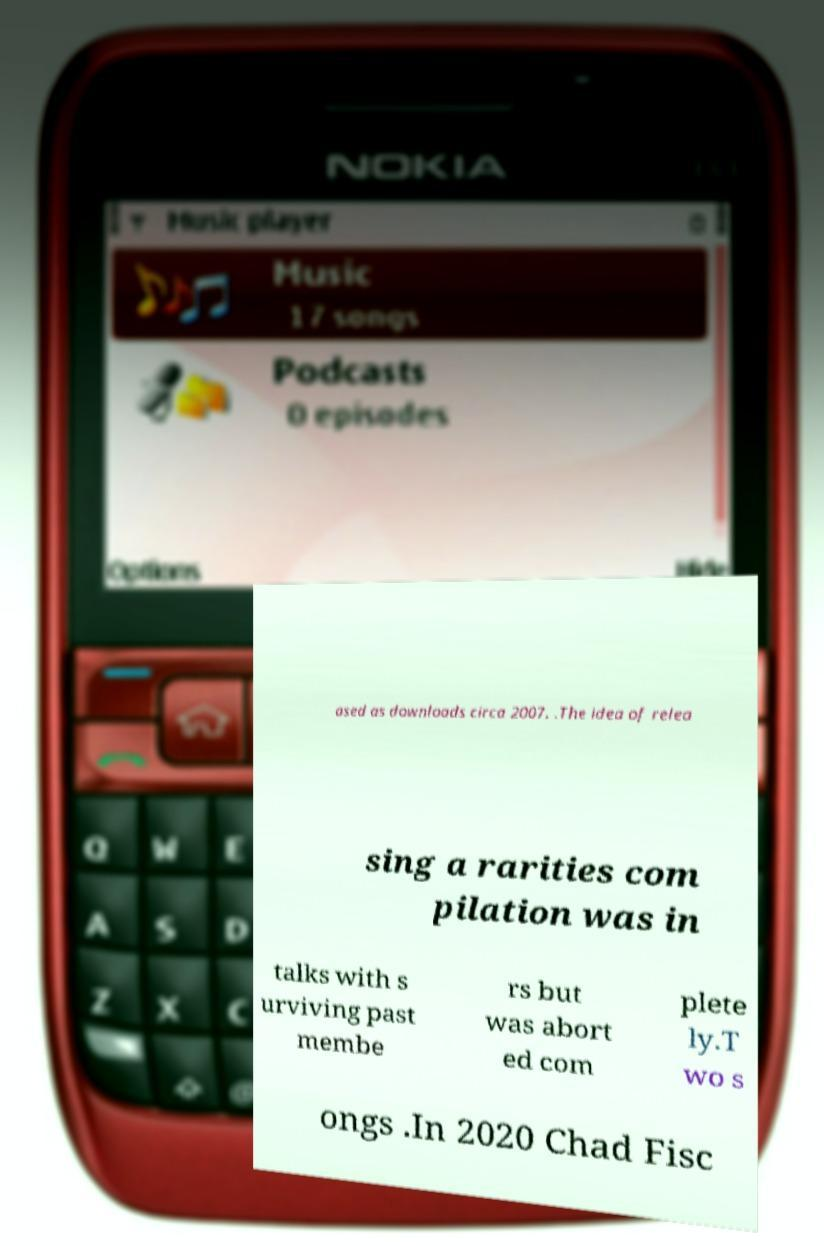Please identify and transcribe the text found in this image. ased as downloads circa 2007. .The idea of relea sing a rarities com pilation was in talks with s urviving past membe rs but was abort ed com plete ly.T wo s ongs .In 2020 Chad Fisc 